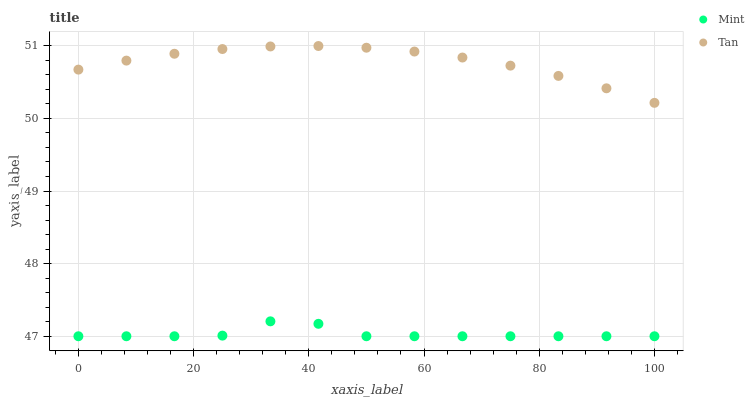Does Mint have the minimum area under the curve?
Answer yes or no. Yes. Does Tan have the maximum area under the curve?
Answer yes or no. Yes. Does Mint have the maximum area under the curve?
Answer yes or no. No. Is Tan the smoothest?
Answer yes or no. Yes. Is Mint the roughest?
Answer yes or no. Yes. Is Mint the smoothest?
Answer yes or no. No. Does Mint have the lowest value?
Answer yes or no. Yes. Does Tan have the highest value?
Answer yes or no. Yes. Does Mint have the highest value?
Answer yes or no. No. Is Mint less than Tan?
Answer yes or no. Yes. Is Tan greater than Mint?
Answer yes or no. Yes. Does Mint intersect Tan?
Answer yes or no. No. 